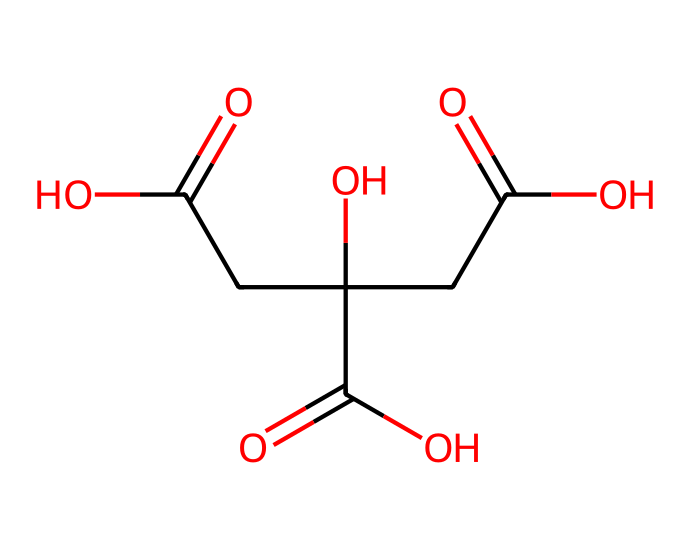What is the name of this chemical? The SMILES representation corresponds to citric acid, a well-known organic acid found in citrus fruits like lemons.
Answer: citric acid How many carboxylic acid groups are present in this molecule? Upon analyzing the structure, we can identify three parts in the SMILES that indicate carboxylic acid functions (the -COOH parts), showing three such groups in citric acid.
Answer: three What is the total number of carbon atoms in this molecule? By breaking down the SMILES notation, we can count the carbon atoms denoted by 'C'. In the structure, there are six 'C' symbols present, representing six carbon atoms.
Answer: six How many hydroxyl (–OH) groups are in citric acid? The structure shows that there is one hydroxyl (–OH) group represented by 'O' connected to a carbon atom, contributing to the overall makeup of citric acid.
Answer: one Considering citric acid is an electrolyte, how does it behave in a solution? Citric acid dissociates in water to release hydrogen ions (H+), making the solution acidic and allowing it to conduct electricity as an electrolyte does.
Answer: dissociates What is the type of bond primarily found between the carbon and oxygen atoms in this compound? In citric acid, the bond between carbon and oxygen is mainly a covalent bond, where electrons are shared between the atoms, characterizing most of its framework.
Answer: covalent bond How many total atoms are there in citric acid? By adding up the total atoms in the structure indicated by the SMILES (6 carbons, 8 oxygens, and 8 hydrogens), we find the sum is 22 atoms in total.
Answer: twenty-two 